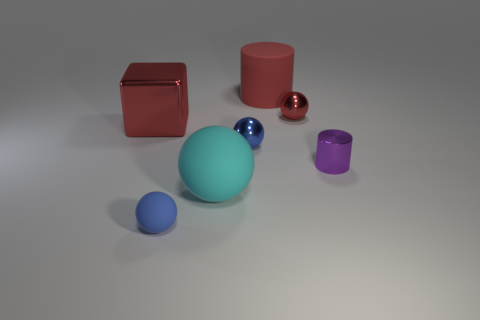How many tiny blue metal balls are there? 1 